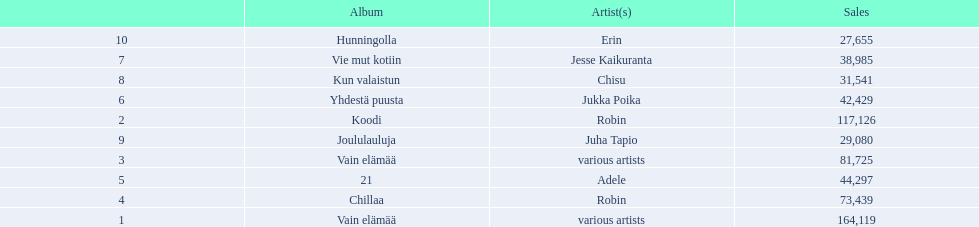What are all the album titles? Vain elämää, Koodi, Vain elämää, Chillaa, 21, Yhdestä puusta, Vie mut kotiin, Kun valaistun, Joululauluja, Hunningolla. Which artists were on the albums? Various artists, robin, various artists, robin, adele, jukka poika, jesse kaikuranta, chisu, juha tapio, erin. Along with chillaa, which other album featured robin? Koodi. 